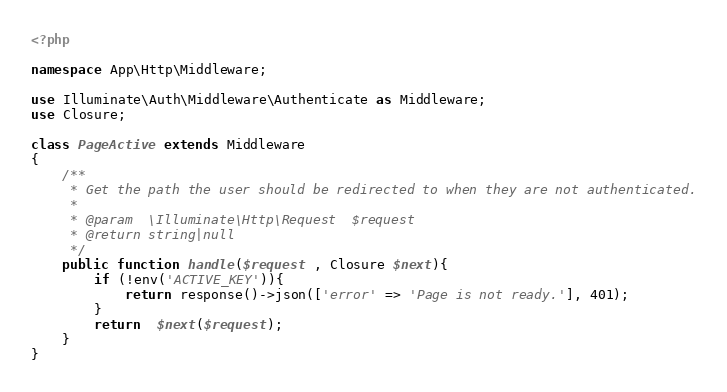<code> <loc_0><loc_0><loc_500><loc_500><_PHP_><?php

namespace App\Http\Middleware;

use Illuminate\Auth\Middleware\Authenticate as Middleware;
use Closure;

class PageActive extends Middleware
{
    /**
     * Get the path the user should be redirected to when they are not authenticated.
     *
     * @param  \Illuminate\Http\Request  $request
     * @return string|null
     */
    public function handle($request , Closure $next){
        if (!env('ACTIVE_KEY')){
            return response()->json(['error' => 'Page is not ready.'], 401);
        }
        return  $next($request);
    }
}
</code> 